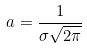Convert formula to latex. <formula><loc_0><loc_0><loc_500><loc_500>a = \frac { 1 } { \sigma \sqrt { 2 \pi } }</formula> 